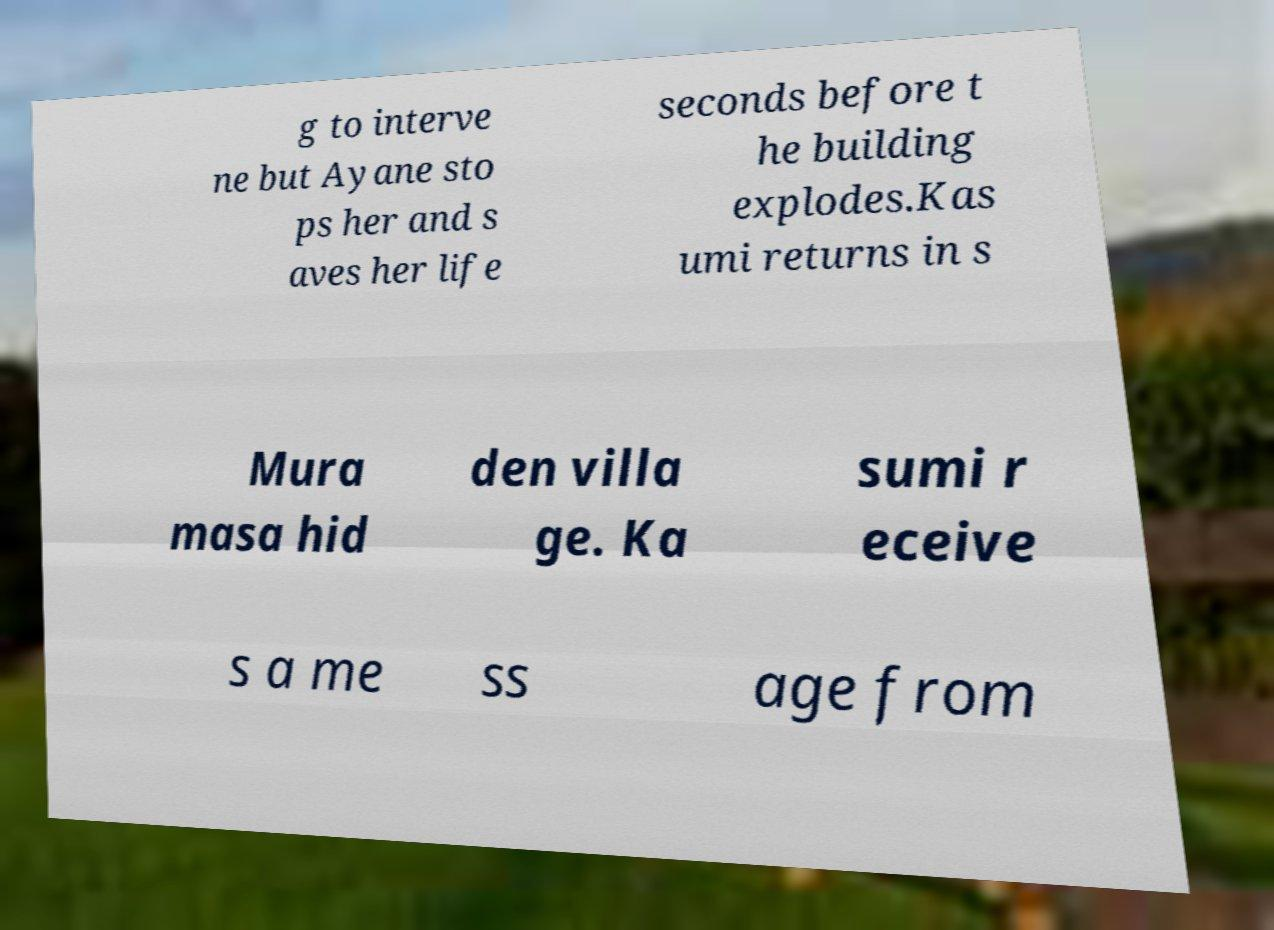Could you assist in decoding the text presented in this image and type it out clearly? g to interve ne but Ayane sto ps her and s aves her life seconds before t he building explodes.Kas umi returns in s Mura masa hid den villa ge. Ka sumi r eceive s a me ss age from 